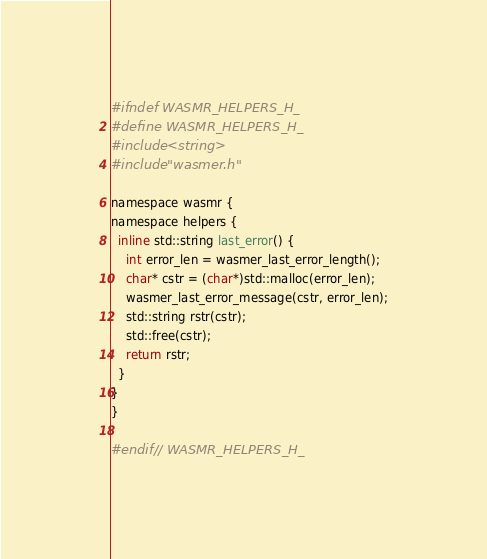<code> <loc_0><loc_0><loc_500><loc_500><_C_>#ifndef WASMR_HELPERS_H_
#define WASMR_HELPERS_H_
#include <string>
#include "wasmer.h"

namespace wasmr {
namespace helpers {
  inline std::string last_error() {
    int error_len = wasmer_last_error_length();
    char* cstr = (char*)std::malloc(error_len);
    wasmer_last_error_message(cstr, error_len);
    std::string rstr(cstr);
    std::free(cstr);
    return rstr;
  }
}
}

#endif // WASMR_HELPERS_H_
</code> 